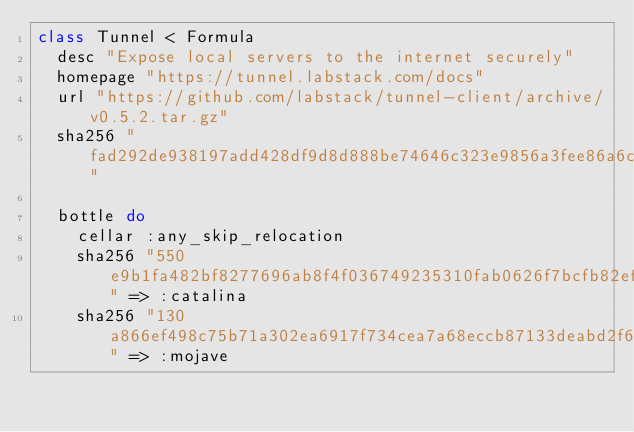<code> <loc_0><loc_0><loc_500><loc_500><_Ruby_>class Tunnel < Formula
  desc "Expose local servers to the internet securely"
  homepage "https://tunnel.labstack.com/docs"
  url "https://github.com/labstack/tunnel-client/archive/v0.5.2.tar.gz"
  sha256 "fad292de938197add428df9d8d888be74646c323e9856a3fee86a6c70a94b2c6"

  bottle do
    cellar :any_skip_relocation
    sha256 "550e9b1fa482bf8277696ab8f4f036749235310fab0626f7bcfb82efe13f4c91" => :catalina
    sha256 "130a866ef498c75b71a302ea6917f734cea7a68eccb87133deabd2f6122e48bd" => :mojave</code> 